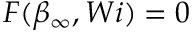Convert formula to latex. <formula><loc_0><loc_0><loc_500><loc_500>F ( \beta _ { \infty } , W i ) = 0</formula> 